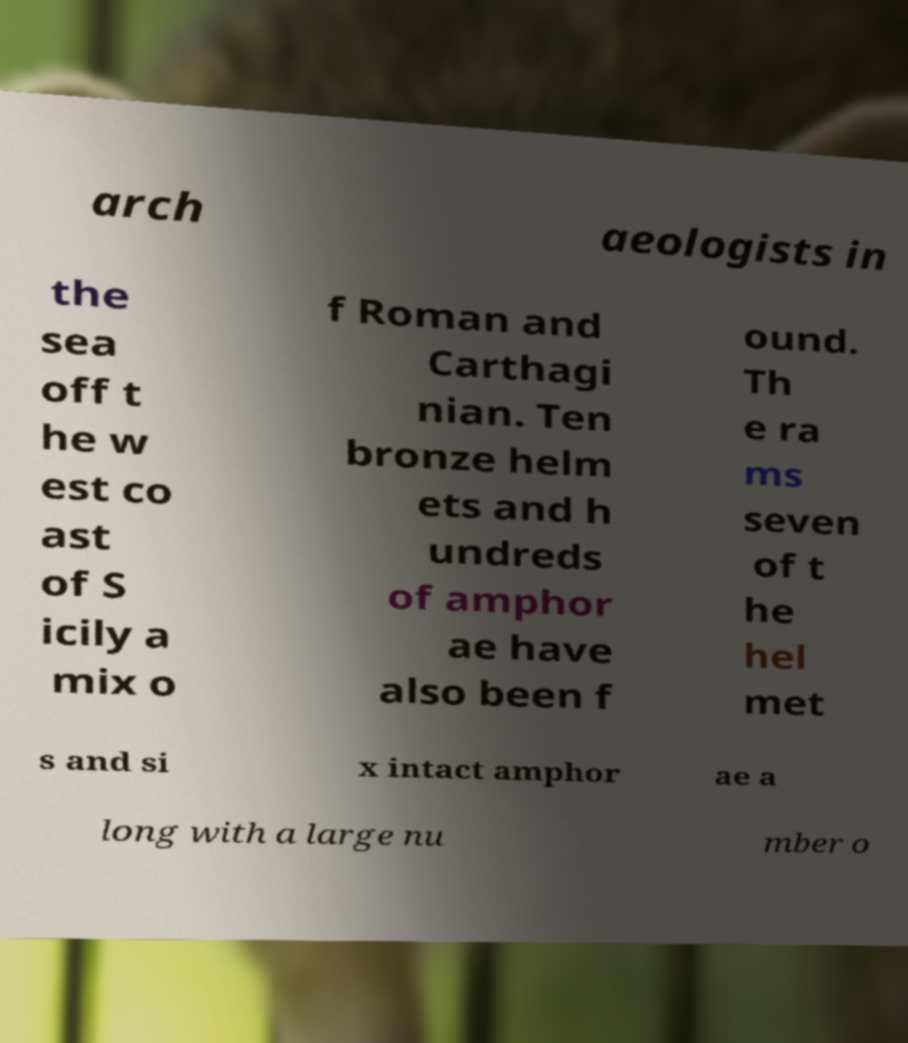Could you assist in decoding the text presented in this image and type it out clearly? arch aeologists in the sea off t he w est co ast of S icily a mix o f Roman and Carthagi nian. Ten bronze helm ets and h undreds of amphor ae have also been f ound. Th e ra ms seven of t he hel met s and si x intact amphor ae a long with a large nu mber o 